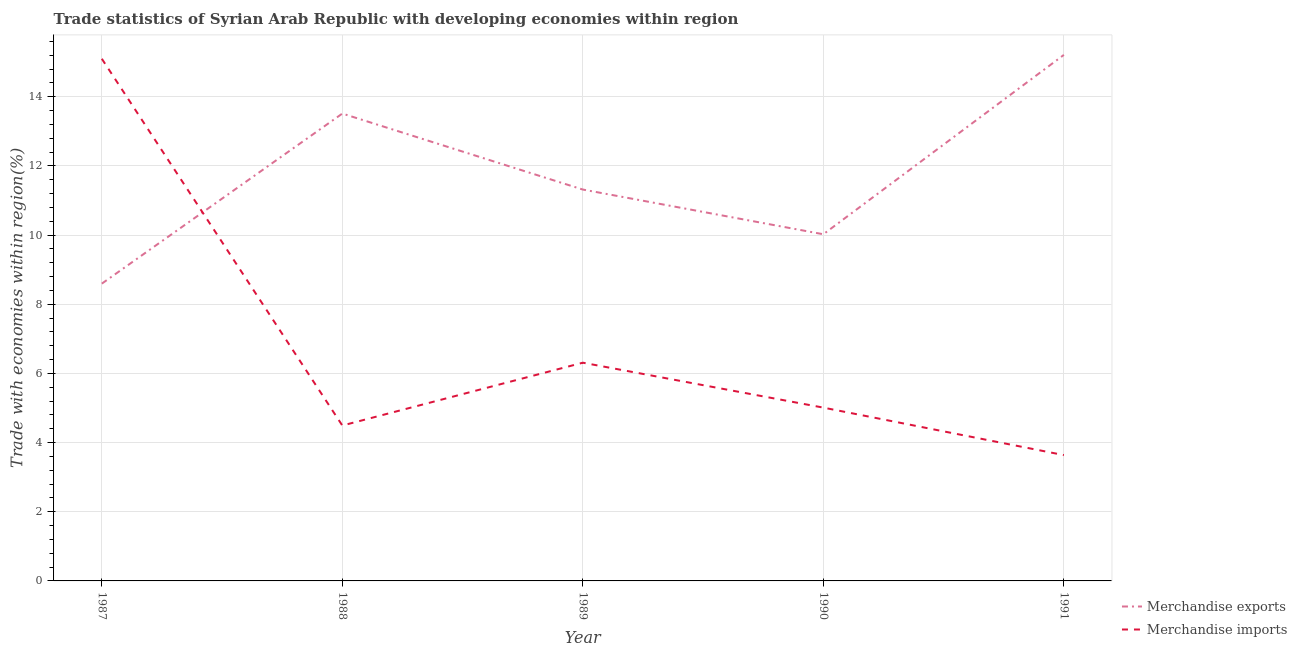How many different coloured lines are there?
Provide a short and direct response. 2. Does the line corresponding to merchandise imports intersect with the line corresponding to merchandise exports?
Your answer should be compact. Yes. What is the merchandise exports in 1990?
Offer a terse response. 10.02. Across all years, what is the maximum merchandise imports?
Your answer should be very brief. 15.1. Across all years, what is the minimum merchandise imports?
Give a very brief answer. 3.64. In which year was the merchandise imports maximum?
Offer a very short reply. 1987. What is the total merchandise exports in the graph?
Provide a short and direct response. 58.66. What is the difference between the merchandise exports in 1988 and that in 1991?
Your response must be concise. -1.7. What is the difference between the merchandise exports in 1988 and the merchandise imports in 1990?
Your response must be concise. 8.5. What is the average merchandise imports per year?
Your answer should be very brief. 6.91. In the year 1990, what is the difference between the merchandise exports and merchandise imports?
Your answer should be compact. 5.01. In how many years, is the merchandise exports greater than 7.2 %?
Your response must be concise. 5. What is the ratio of the merchandise imports in 1987 to that in 1991?
Provide a short and direct response. 4.15. What is the difference between the highest and the second highest merchandise exports?
Your response must be concise. 1.7. What is the difference between the highest and the lowest merchandise imports?
Offer a terse response. 11.46. Is the sum of the merchandise exports in 1987 and 1990 greater than the maximum merchandise imports across all years?
Keep it short and to the point. Yes. Does the merchandise exports monotonically increase over the years?
Ensure brevity in your answer.  No. Is the merchandise imports strictly less than the merchandise exports over the years?
Provide a short and direct response. No. How many years are there in the graph?
Your response must be concise. 5. Are the values on the major ticks of Y-axis written in scientific E-notation?
Offer a terse response. No. Does the graph contain grids?
Offer a very short reply. Yes. Where does the legend appear in the graph?
Keep it short and to the point. Bottom right. What is the title of the graph?
Offer a very short reply. Trade statistics of Syrian Arab Republic with developing economies within region. Does "% of gross capital formation" appear as one of the legend labels in the graph?
Offer a very short reply. No. What is the label or title of the Y-axis?
Keep it short and to the point. Trade with economies within region(%). What is the Trade with economies within region(%) in Merchandise exports in 1987?
Provide a short and direct response. 8.6. What is the Trade with economies within region(%) of Merchandise imports in 1987?
Keep it short and to the point. 15.1. What is the Trade with economies within region(%) in Merchandise exports in 1988?
Offer a very short reply. 13.51. What is the Trade with economies within region(%) in Merchandise imports in 1988?
Provide a succinct answer. 4.49. What is the Trade with economies within region(%) in Merchandise exports in 1989?
Offer a terse response. 11.32. What is the Trade with economies within region(%) in Merchandise imports in 1989?
Your answer should be compact. 6.31. What is the Trade with economies within region(%) in Merchandise exports in 1990?
Your answer should be very brief. 10.02. What is the Trade with economies within region(%) of Merchandise imports in 1990?
Offer a terse response. 5.01. What is the Trade with economies within region(%) in Merchandise exports in 1991?
Make the answer very short. 15.21. What is the Trade with economies within region(%) in Merchandise imports in 1991?
Offer a very short reply. 3.64. Across all years, what is the maximum Trade with economies within region(%) in Merchandise exports?
Provide a short and direct response. 15.21. Across all years, what is the maximum Trade with economies within region(%) in Merchandise imports?
Your response must be concise. 15.1. Across all years, what is the minimum Trade with economies within region(%) in Merchandise exports?
Offer a very short reply. 8.6. Across all years, what is the minimum Trade with economies within region(%) of Merchandise imports?
Make the answer very short. 3.64. What is the total Trade with economies within region(%) in Merchandise exports in the graph?
Keep it short and to the point. 58.66. What is the total Trade with economies within region(%) in Merchandise imports in the graph?
Provide a short and direct response. 34.55. What is the difference between the Trade with economies within region(%) of Merchandise exports in 1987 and that in 1988?
Offer a very short reply. -4.92. What is the difference between the Trade with economies within region(%) of Merchandise imports in 1987 and that in 1988?
Make the answer very short. 10.6. What is the difference between the Trade with economies within region(%) of Merchandise exports in 1987 and that in 1989?
Provide a short and direct response. -2.72. What is the difference between the Trade with economies within region(%) in Merchandise imports in 1987 and that in 1989?
Your answer should be compact. 8.79. What is the difference between the Trade with economies within region(%) of Merchandise exports in 1987 and that in 1990?
Give a very brief answer. -1.43. What is the difference between the Trade with economies within region(%) of Merchandise imports in 1987 and that in 1990?
Your response must be concise. 10.09. What is the difference between the Trade with economies within region(%) of Merchandise exports in 1987 and that in 1991?
Your answer should be compact. -6.61. What is the difference between the Trade with economies within region(%) in Merchandise imports in 1987 and that in 1991?
Your answer should be very brief. 11.46. What is the difference between the Trade with economies within region(%) in Merchandise exports in 1988 and that in 1989?
Keep it short and to the point. 2.2. What is the difference between the Trade with economies within region(%) of Merchandise imports in 1988 and that in 1989?
Ensure brevity in your answer.  -1.82. What is the difference between the Trade with economies within region(%) of Merchandise exports in 1988 and that in 1990?
Your response must be concise. 3.49. What is the difference between the Trade with economies within region(%) in Merchandise imports in 1988 and that in 1990?
Your answer should be compact. -0.52. What is the difference between the Trade with economies within region(%) in Merchandise exports in 1988 and that in 1991?
Provide a short and direct response. -1.7. What is the difference between the Trade with economies within region(%) of Merchandise imports in 1988 and that in 1991?
Ensure brevity in your answer.  0.86. What is the difference between the Trade with economies within region(%) in Merchandise exports in 1989 and that in 1990?
Keep it short and to the point. 1.29. What is the difference between the Trade with economies within region(%) in Merchandise imports in 1989 and that in 1990?
Keep it short and to the point. 1.3. What is the difference between the Trade with economies within region(%) in Merchandise exports in 1989 and that in 1991?
Keep it short and to the point. -3.89. What is the difference between the Trade with economies within region(%) of Merchandise imports in 1989 and that in 1991?
Keep it short and to the point. 2.67. What is the difference between the Trade with economies within region(%) in Merchandise exports in 1990 and that in 1991?
Offer a terse response. -5.19. What is the difference between the Trade with economies within region(%) of Merchandise imports in 1990 and that in 1991?
Offer a very short reply. 1.37. What is the difference between the Trade with economies within region(%) of Merchandise exports in 1987 and the Trade with economies within region(%) of Merchandise imports in 1988?
Your response must be concise. 4.1. What is the difference between the Trade with economies within region(%) in Merchandise exports in 1987 and the Trade with economies within region(%) in Merchandise imports in 1989?
Offer a terse response. 2.29. What is the difference between the Trade with economies within region(%) of Merchandise exports in 1987 and the Trade with economies within region(%) of Merchandise imports in 1990?
Your answer should be compact. 3.58. What is the difference between the Trade with economies within region(%) of Merchandise exports in 1987 and the Trade with economies within region(%) of Merchandise imports in 1991?
Make the answer very short. 4.96. What is the difference between the Trade with economies within region(%) in Merchandise exports in 1988 and the Trade with economies within region(%) in Merchandise imports in 1989?
Your response must be concise. 7.2. What is the difference between the Trade with economies within region(%) in Merchandise exports in 1988 and the Trade with economies within region(%) in Merchandise imports in 1990?
Provide a short and direct response. 8.5. What is the difference between the Trade with economies within region(%) in Merchandise exports in 1988 and the Trade with economies within region(%) in Merchandise imports in 1991?
Make the answer very short. 9.88. What is the difference between the Trade with economies within region(%) in Merchandise exports in 1989 and the Trade with economies within region(%) in Merchandise imports in 1990?
Provide a succinct answer. 6.31. What is the difference between the Trade with economies within region(%) in Merchandise exports in 1989 and the Trade with economies within region(%) in Merchandise imports in 1991?
Your answer should be compact. 7.68. What is the difference between the Trade with economies within region(%) in Merchandise exports in 1990 and the Trade with economies within region(%) in Merchandise imports in 1991?
Provide a succinct answer. 6.39. What is the average Trade with economies within region(%) of Merchandise exports per year?
Provide a succinct answer. 11.73. What is the average Trade with economies within region(%) of Merchandise imports per year?
Offer a very short reply. 6.91. In the year 1987, what is the difference between the Trade with economies within region(%) of Merchandise exports and Trade with economies within region(%) of Merchandise imports?
Provide a succinct answer. -6.5. In the year 1988, what is the difference between the Trade with economies within region(%) of Merchandise exports and Trade with economies within region(%) of Merchandise imports?
Your answer should be very brief. 9.02. In the year 1989, what is the difference between the Trade with economies within region(%) in Merchandise exports and Trade with economies within region(%) in Merchandise imports?
Your answer should be very brief. 5.01. In the year 1990, what is the difference between the Trade with economies within region(%) in Merchandise exports and Trade with economies within region(%) in Merchandise imports?
Offer a very short reply. 5.01. In the year 1991, what is the difference between the Trade with economies within region(%) in Merchandise exports and Trade with economies within region(%) in Merchandise imports?
Your response must be concise. 11.57. What is the ratio of the Trade with economies within region(%) of Merchandise exports in 1987 to that in 1988?
Ensure brevity in your answer.  0.64. What is the ratio of the Trade with economies within region(%) in Merchandise imports in 1987 to that in 1988?
Provide a short and direct response. 3.36. What is the ratio of the Trade with economies within region(%) in Merchandise exports in 1987 to that in 1989?
Give a very brief answer. 0.76. What is the ratio of the Trade with economies within region(%) in Merchandise imports in 1987 to that in 1989?
Give a very brief answer. 2.39. What is the ratio of the Trade with economies within region(%) of Merchandise exports in 1987 to that in 1990?
Keep it short and to the point. 0.86. What is the ratio of the Trade with economies within region(%) of Merchandise imports in 1987 to that in 1990?
Offer a very short reply. 3.01. What is the ratio of the Trade with economies within region(%) of Merchandise exports in 1987 to that in 1991?
Provide a short and direct response. 0.57. What is the ratio of the Trade with economies within region(%) of Merchandise imports in 1987 to that in 1991?
Keep it short and to the point. 4.15. What is the ratio of the Trade with economies within region(%) in Merchandise exports in 1988 to that in 1989?
Your answer should be very brief. 1.19. What is the ratio of the Trade with economies within region(%) in Merchandise imports in 1988 to that in 1989?
Your response must be concise. 0.71. What is the ratio of the Trade with economies within region(%) in Merchandise exports in 1988 to that in 1990?
Make the answer very short. 1.35. What is the ratio of the Trade with economies within region(%) of Merchandise imports in 1988 to that in 1990?
Your answer should be very brief. 0.9. What is the ratio of the Trade with economies within region(%) of Merchandise exports in 1988 to that in 1991?
Ensure brevity in your answer.  0.89. What is the ratio of the Trade with economies within region(%) of Merchandise imports in 1988 to that in 1991?
Your answer should be compact. 1.24. What is the ratio of the Trade with economies within region(%) of Merchandise exports in 1989 to that in 1990?
Your answer should be very brief. 1.13. What is the ratio of the Trade with economies within region(%) in Merchandise imports in 1989 to that in 1990?
Keep it short and to the point. 1.26. What is the ratio of the Trade with economies within region(%) in Merchandise exports in 1989 to that in 1991?
Your answer should be compact. 0.74. What is the ratio of the Trade with economies within region(%) in Merchandise imports in 1989 to that in 1991?
Give a very brief answer. 1.73. What is the ratio of the Trade with economies within region(%) in Merchandise exports in 1990 to that in 1991?
Your answer should be compact. 0.66. What is the ratio of the Trade with economies within region(%) in Merchandise imports in 1990 to that in 1991?
Offer a terse response. 1.38. What is the difference between the highest and the second highest Trade with economies within region(%) in Merchandise exports?
Your answer should be compact. 1.7. What is the difference between the highest and the second highest Trade with economies within region(%) in Merchandise imports?
Give a very brief answer. 8.79. What is the difference between the highest and the lowest Trade with economies within region(%) of Merchandise exports?
Your response must be concise. 6.61. What is the difference between the highest and the lowest Trade with economies within region(%) of Merchandise imports?
Your answer should be compact. 11.46. 